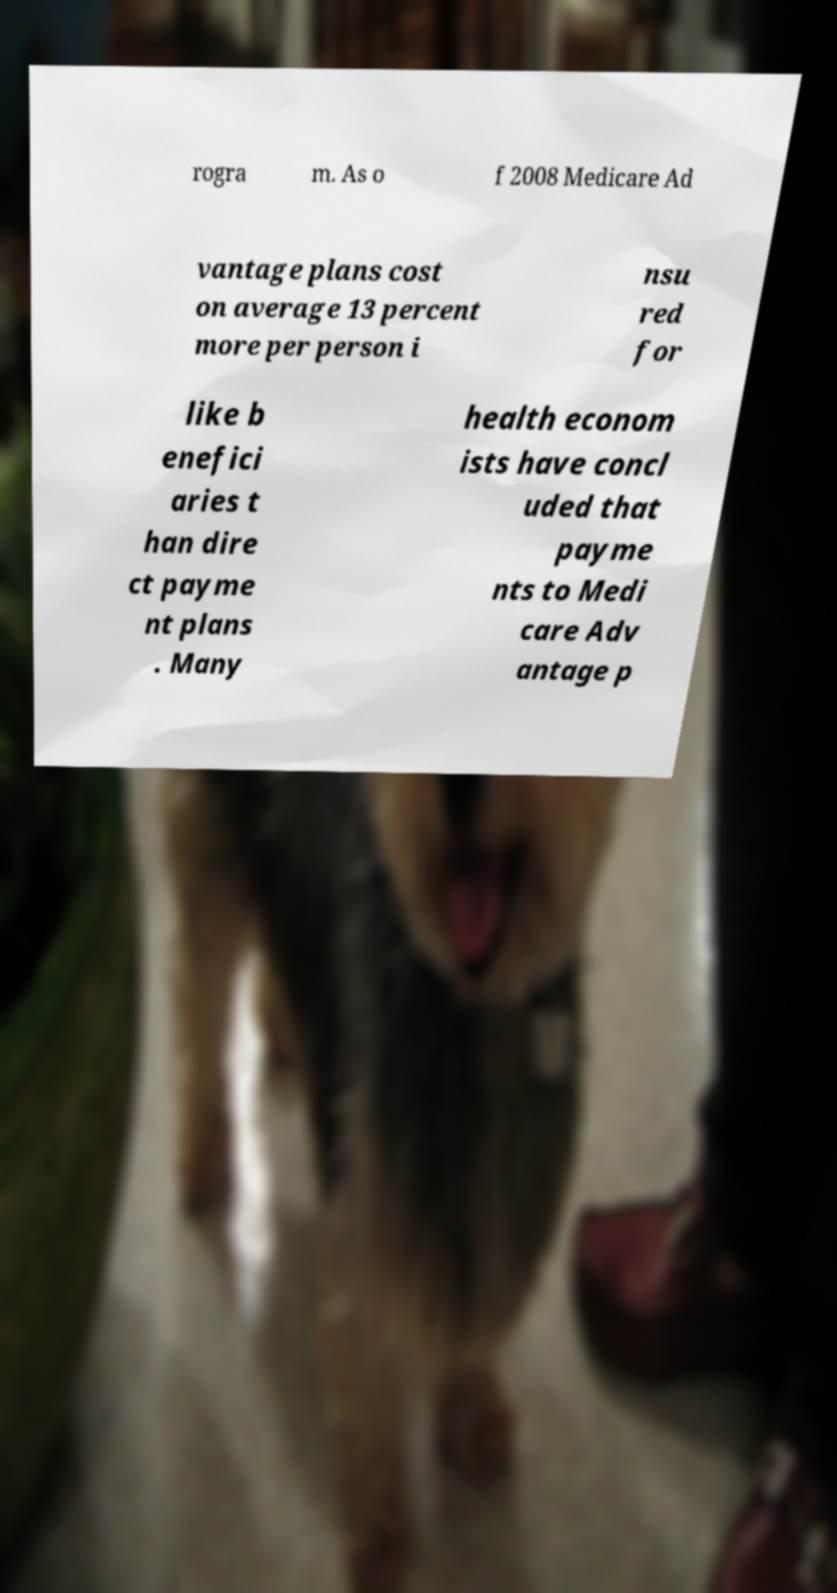Can you read and provide the text displayed in the image?This photo seems to have some interesting text. Can you extract and type it out for me? rogra m. As o f 2008 Medicare Ad vantage plans cost on average 13 percent more per person i nsu red for like b enefici aries t han dire ct payme nt plans . Many health econom ists have concl uded that payme nts to Medi care Adv antage p 